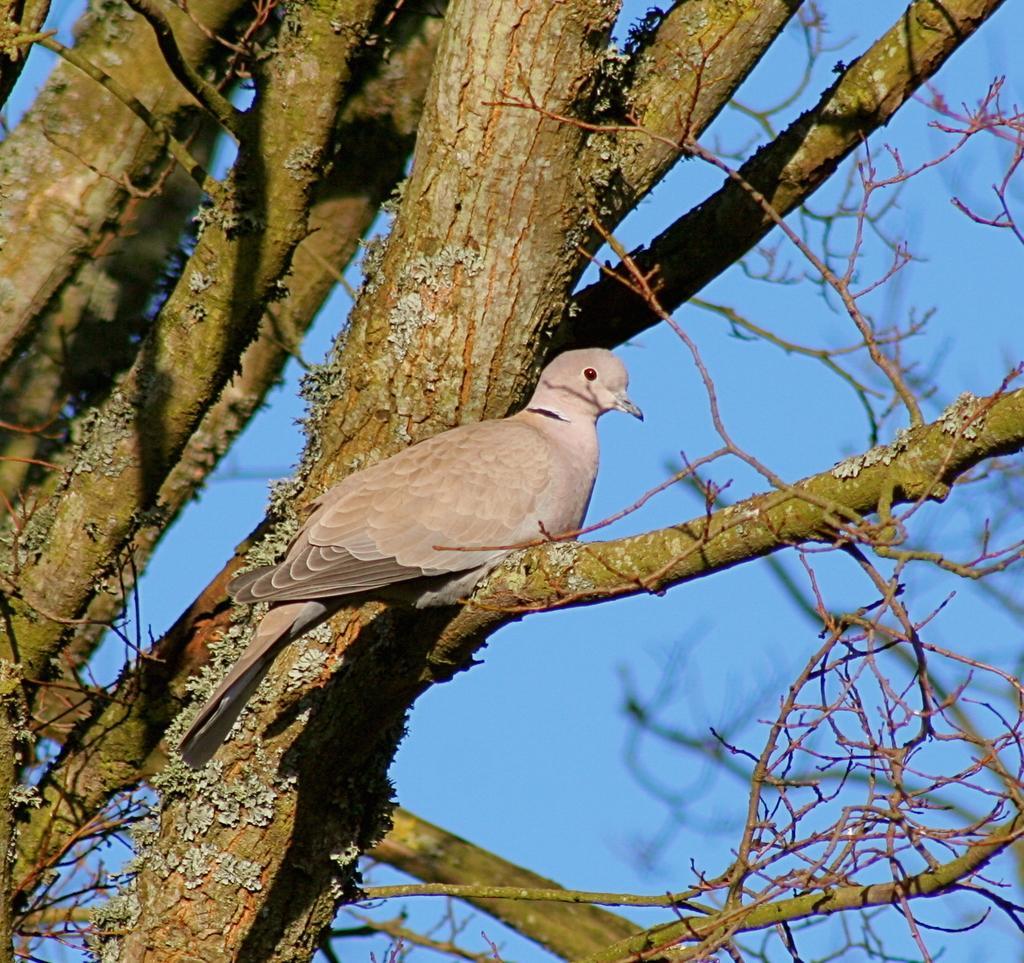Can you describe this image briefly? In this image we can see a bird sitting on the branch of a tree and sky. 